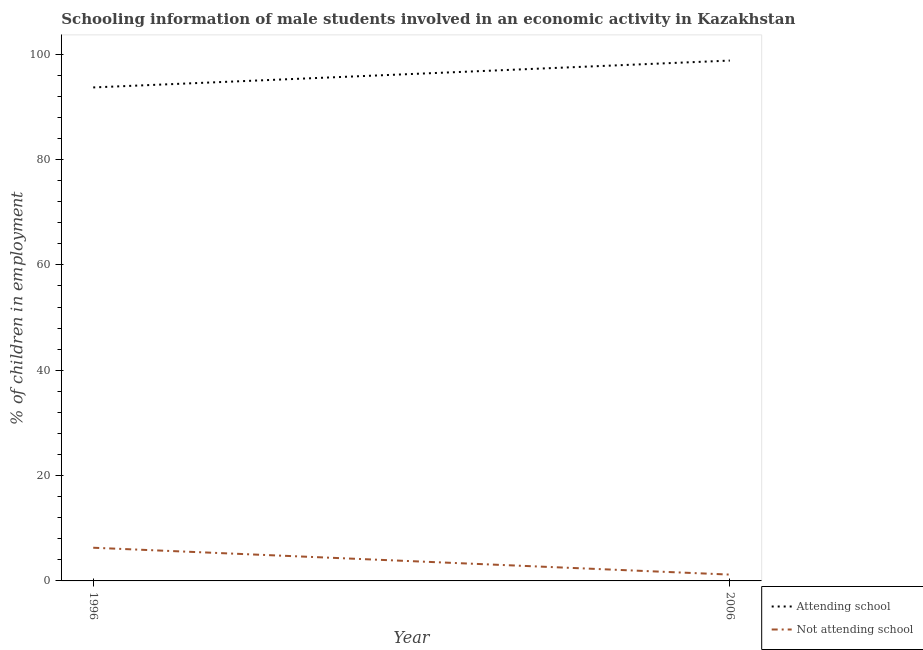How many different coloured lines are there?
Your answer should be compact. 2. Does the line corresponding to percentage of employed males who are attending school intersect with the line corresponding to percentage of employed males who are not attending school?
Your answer should be compact. No. Is the number of lines equal to the number of legend labels?
Provide a succinct answer. Yes. Across all years, what is the minimum percentage of employed males who are attending school?
Provide a short and direct response. 93.7. In which year was the percentage of employed males who are attending school maximum?
Provide a short and direct response. 2006. What is the total percentage of employed males who are not attending school in the graph?
Your response must be concise. 7.5. What is the difference between the percentage of employed males who are attending school in 1996 and that in 2006?
Your answer should be very brief. -5.1. What is the difference between the percentage of employed males who are attending school in 1996 and the percentage of employed males who are not attending school in 2006?
Your answer should be compact. 92.5. What is the average percentage of employed males who are attending school per year?
Offer a terse response. 96.25. In the year 2006, what is the difference between the percentage of employed males who are attending school and percentage of employed males who are not attending school?
Your answer should be very brief. 97.6. What is the ratio of the percentage of employed males who are attending school in 1996 to that in 2006?
Offer a terse response. 0.95. Does the percentage of employed males who are not attending school monotonically increase over the years?
Provide a short and direct response. No. How many lines are there?
Your answer should be very brief. 2. Are the values on the major ticks of Y-axis written in scientific E-notation?
Your answer should be compact. No. Does the graph contain any zero values?
Offer a very short reply. No. Does the graph contain grids?
Keep it short and to the point. No. What is the title of the graph?
Provide a short and direct response. Schooling information of male students involved in an economic activity in Kazakhstan. What is the label or title of the X-axis?
Give a very brief answer. Year. What is the label or title of the Y-axis?
Provide a succinct answer. % of children in employment. What is the % of children in employment of Attending school in 1996?
Keep it short and to the point. 93.7. What is the % of children in employment of Not attending school in 1996?
Keep it short and to the point. 6.3. What is the % of children in employment of Attending school in 2006?
Offer a terse response. 98.8. What is the % of children in employment of Not attending school in 2006?
Provide a short and direct response. 1.2. Across all years, what is the maximum % of children in employment of Attending school?
Your answer should be compact. 98.8. Across all years, what is the minimum % of children in employment in Attending school?
Your answer should be very brief. 93.7. Across all years, what is the minimum % of children in employment in Not attending school?
Keep it short and to the point. 1.2. What is the total % of children in employment of Attending school in the graph?
Give a very brief answer. 192.5. What is the total % of children in employment of Not attending school in the graph?
Provide a succinct answer. 7.5. What is the difference between the % of children in employment of Attending school in 1996 and that in 2006?
Keep it short and to the point. -5.1. What is the difference between the % of children in employment in Attending school in 1996 and the % of children in employment in Not attending school in 2006?
Keep it short and to the point. 92.5. What is the average % of children in employment in Attending school per year?
Your answer should be compact. 96.25. What is the average % of children in employment in Not attending school per year?
Make the answer very short. 3.75. In the year 1996, what is the difference between the % of children in employment of Attending school and % of children in employment of Not attending school?
Offer a terse response. 87.4. In the year 2006, what is the difference between the % of children in employment of Attending school and % of children in employment of Not attending school?
Ensure brevity in your answer.  97.6. What is the ratio of the % of children in employment of Attending school in 1996 to that in 2006?
Offer a terse response. 0.95. What is the ratio of the % of children in employment of Not attending school in 1996 to that in 2006?
Give a very brief answer. 5.25. What is the difference between the highest and the second highest % of children in employment of Attending school?
Provide a succinct answer. 5.1. 